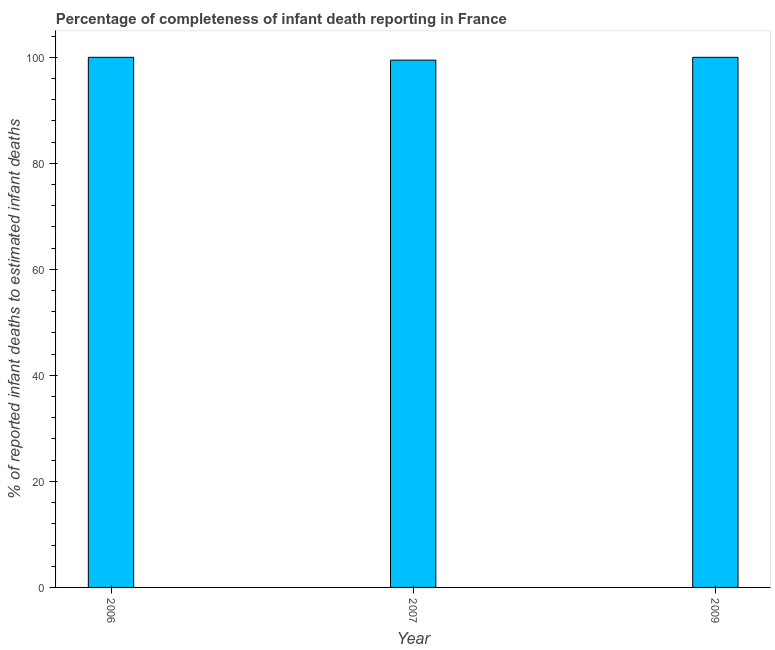What is the title of the graph?
Provide a short and direct response. Percentage of completeness of infant death reporting in France. What is the label or title of the X-axis?
Ensure brevity in your answer.  Year. What is the label or title of the Y-axis?
Your response must be concise. % of reported infant deaths to estimated infant deaths. What is the completeness of infant death reporting in 2009?
Your answer should be compact. 100. Across all years, what is the minimum completeness of infant death reporting?
Your answer should be very brief. 99.47. In which year was the completeness of infant death reporting maximum?
Offer a very short reply. 2006. What is the sum of the completeness of infant death reporting?
Give a very brief answer. 299.47. What is the difference between the completeness of infant death reporting in 2006 and 2007?
Your answer should be very brief. 0.53. What is the average completeness of infant death reporting per year?
Your response must be concise. 99.82. Do a majority of the years between 2009 and 2006 (inclusive) have completeness of infant death reporting greater than 64 %?
Keep it short and to the point. Yes. What is the difference between the highest and the second highest completeness of infant death reporting?
Provide a succinct answer. 0. What is the difference between the highest and the lowest completeness of infant death reporting?
Make the answer very short. 0.53. In how many years, is the completeness of infant death reporting greater than the average completeness of infant death reporting taken over all years?
Ensure brevity in your answer.  2. Are all the bars in the graph horizontal?
Give a very brief answer. No. What is the difference between two consecutive major ticks on the Y-axis?
Your answer should be very brief. 20. Are the values on the major ticks of Y-axis written in scientific E-notation?
Your answer should be compact. No. What is the % of reported infant deaths to estimated infant deaths of 2006?
Offer a very short reply. 100. What is the % of reported infant deaths to estimated infant deaths in 2007?
Offer a terse response. 99.47. What is the difference between the % of reported infant deaths to estimated infant deaths in 2006 and 2007?
Make the answer very short. 0.53. What is the difference between the % of reported infant deaths to estimated infant deaths in 2007 and 2009?
Offer a very short reply. -0.53. 